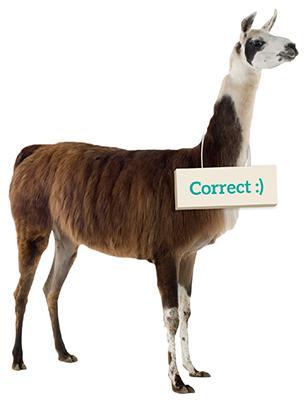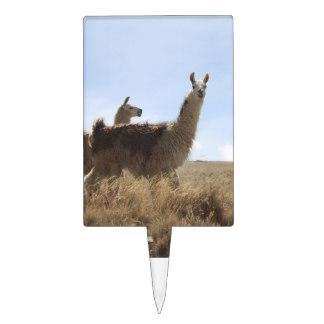The first image is the image on the left, the second image is the image on the right. Examine the images to the left and right. Is the description "There are exactly three llamas." accurate? Answer yes or no. Yes. The first image is the image on the left, the second image is the image on the right. Considering the images on both sides, is "Each image shows a single llama figure, which is standing in profile facing leftward." valid? Answer yes or no. No. 